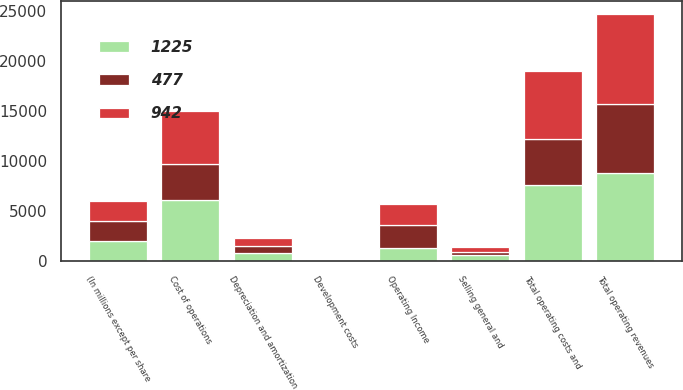Convert chart. <chart><loc_0><loc_0><loc_500><loc_500><stacked_bar_chart><ecel><fcel>(In millions except per share<fcel>Total operating revenues<fcel>Cost of operations<fcel>Depreciation and amortization<fcel>Selling general and<fcel>Development costs<fcel>Total operating costs and<fcel>Operating Income<nl><fcel>1225<fcel>2010<fcel>8849<fcel>6073<fcel>838<fcel>598<fcel>55<fcel>7564<fcel>1308<nl><fcel>942<fcel>2009<fcel>8952<fcel>5323<fcel>818<fcel>550<fcel>48<fcel>6793<fcel>2159<nl><fcel>477<fcel>2008<fcel>6885<fcel>3598<fcel>649<fcel>319<fcel>46<fcel>4612<fcel>2273<nl></chart> 